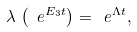<formula> <loc_0><loc_0><loc_500><loc_500>\lambda \, \left ( \ e ^ { E _ { 3 } t } \right ) = \ e ^ { \Lambda t } ,</formula> 